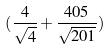Convert formula to latex. <formula><loc_0><loc_0><loc_500><loc_500>( \frac { 4 } { \sqrt { 4 } } + \frac { 4 0 5 } { \sqrt { 2 0 1 } } )</formula> 